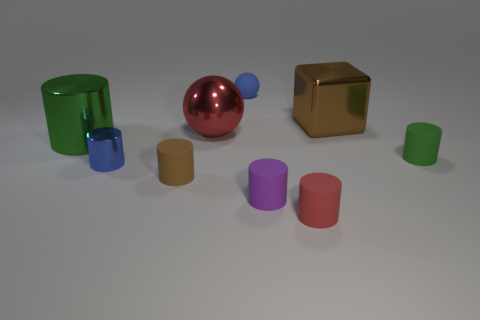Subtract 3 cylinders. How many cylinders are left? 3 Subtract all blue cylinders. How many cylinders are left? 5 Subtract all brown rubber cylinders. How many cylinders are left? 5 Subtract all red cylinders. Subtract all blue spheres. How many cylinders are left? 5 Subtract all blocks. How many objects are left? 8 Add 5 tiny cyan balls. How many tiny cyan balls exist? 5 Subtract 0 cyan cubes. How many objects are left? 9 Subtract all brown shiny cylinders. Subtract all brown matte objects. How many objects are left? 8 Add 8 small blue rubber objects. How many small blue rubber objects are left? 9 